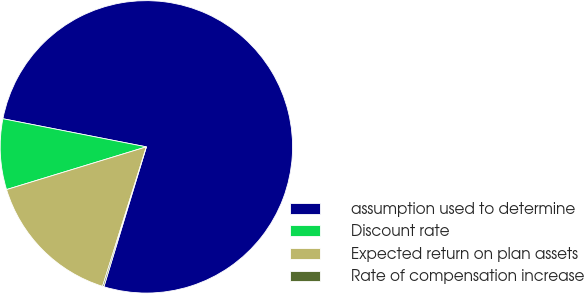<chart> <loc_0><loc_0><loc_500><loc_500><pie_chart><fcel>assumption used to determine<fcel>Discount rate<fcel>Expected return on plan assets<fcel>Rate of compensation increase<nl><fcel>76.61%<fcel>7.8%<fcel>15.44%<fcel>0.15%<nl></chart> 